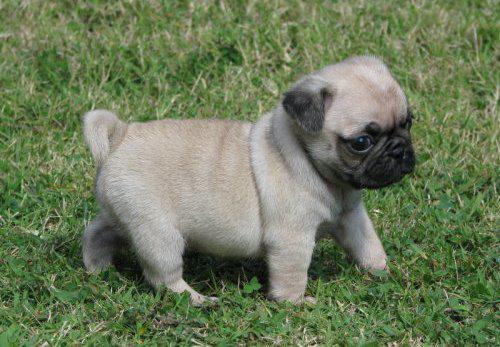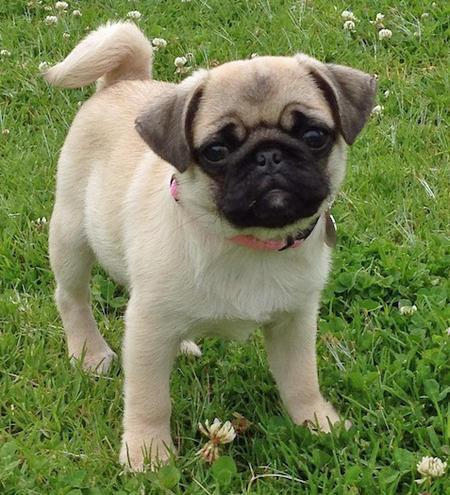The first image is the image on the left, the second image is the image on the right. Evaluate the accuracy of this statement regarding the images: "At least one dog has a visible collar.". Is it true? Answer yes or no. Yes. 